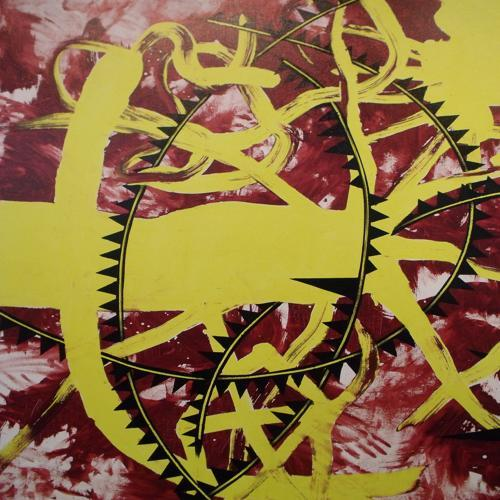Is the composition of the image acceptable? Yes, the composition of the image is acceptable, exhibiting a dynamic balance between color contrasts and abstract shapes that draw the viewer's attention across the canvas. 